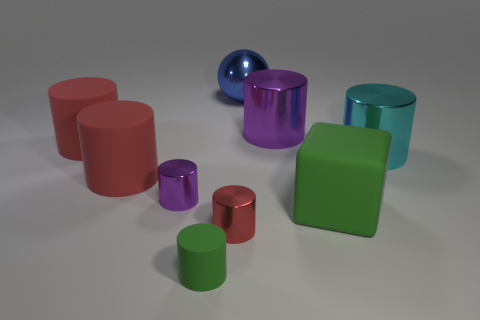Is there any other thing that is the same shape as the blue object?
Give a very brief answer. No. What is the material of the green cylinder that is in front of the big rubber thing on the right side of the purple metal object that is left of the blue shiny sphere?
Make the answer very short. Rubber. There is a cylinder that is the same color as the large cube; what is its material?
Your answer should be very brief. Rubber. How many things are tiny green cylinders or large gray metal cylinders?
Your answer should be compact. 1. Is the purple object that is to the left of the large blue metal thing made of the same material as the green cylinder?
Give a very brief answer. No. How many objects are small cylinders left of the cube or rubber cylinders?
Make the answer very short. 5. There is a ball that is made of the same material as the cyan cylinder; what color is it?
Offer a very short reply. Blue. Is there a green rubber object that has the same size as the red metallic cylinder?
Provide a succinct answer. Yes. Do the small rubber thing that is left of the large blue object and the big block have the same color?
Make the answer very short. Yes. The large metallic object that is both on the left side of the cyan cylinder and in front of the blue shiny object is what color?
Keep it short and to the point. Purple. 